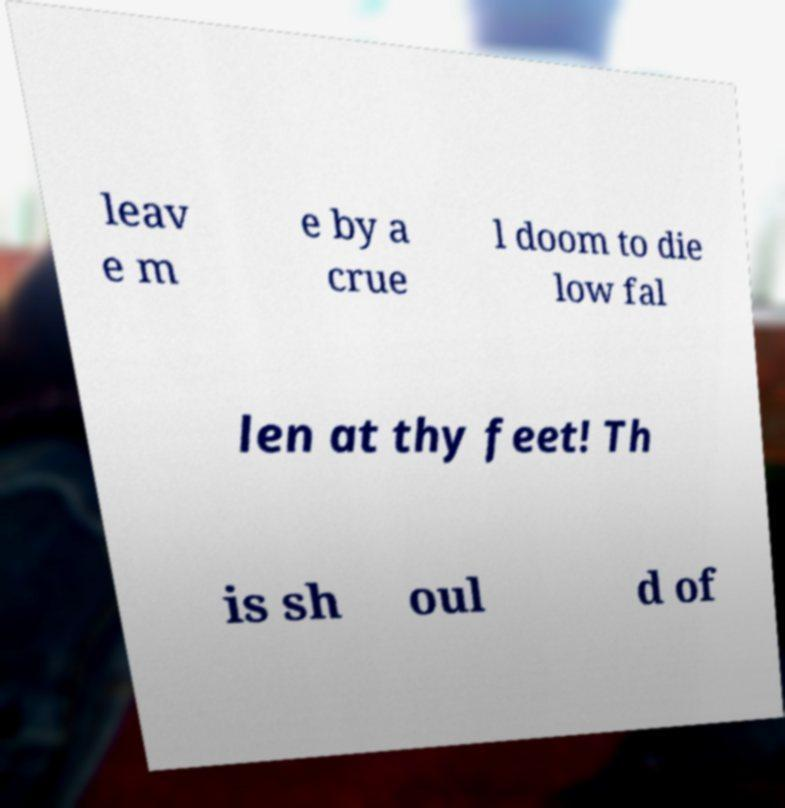I need the written content from this picture converted into text. Can you do that? leav e m e by a crue l doom to die low fal len at thy feet! Th is sh oul d of 